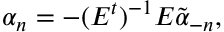<formula> <loc_0><loc_0><loc_500><loc_500>\alpha _ { n } = - ( E ^ { t } ) ^ { - 1 } E \tilde { \alpha } _ { - n } ,</formula> 